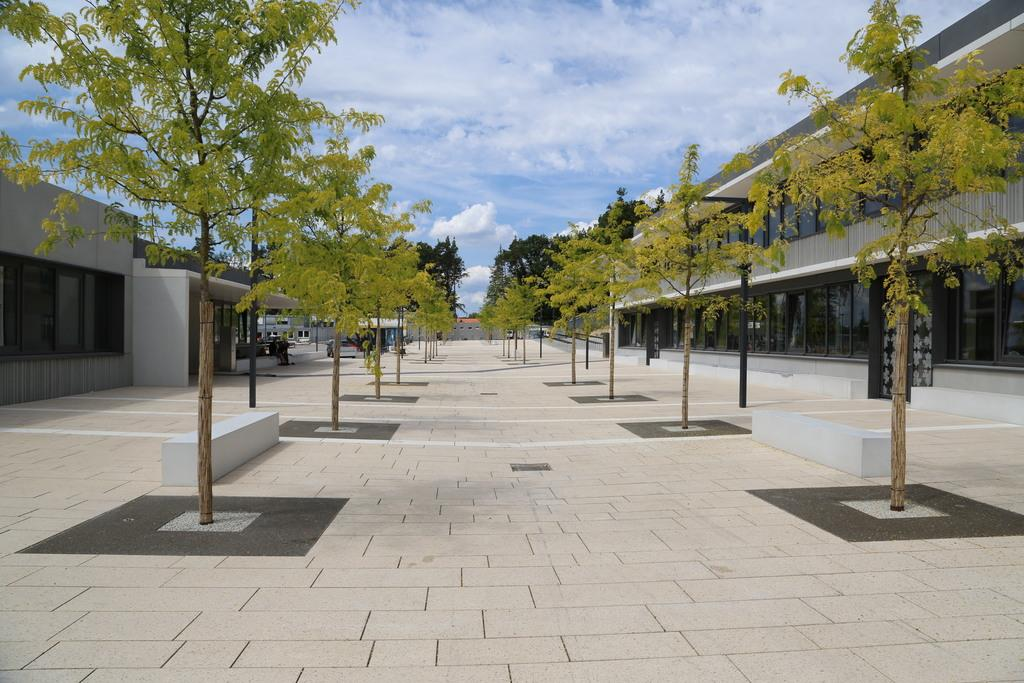What can be seen running through the image? There is a way or path in the image. What type of vegetation is present on either side of the way? There are trees on either side of the way. What type of structures are also present on either side of the way? There are buildings on either side of the way. What is the tendency of the celery to grow in the image? There is no celery present in the image, so it is not possible to determine its tendency to grow. 